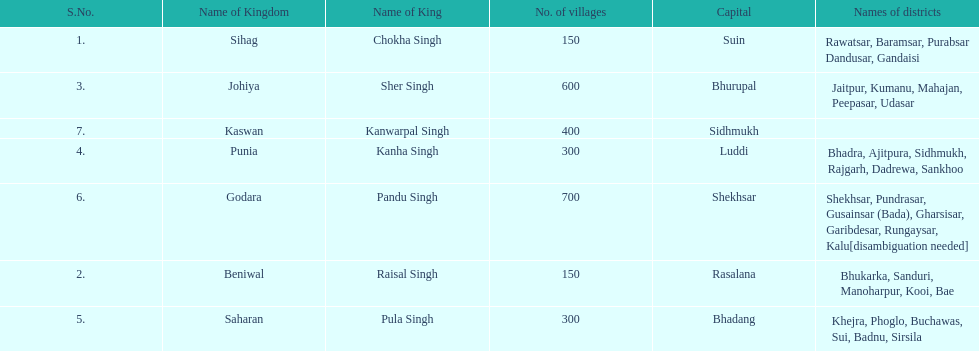What are the number of villages johiya has according to this chart? 600. 